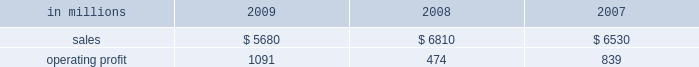Mill in the fourth quarter of 2008 .
This compares with 635000 tons of total downtime in 2008 of which 305000 tons were lack-of-order downtime .
Printing papers in millions 2009 2008 2007 .
North american printing papers net sales in 2009 were $ 2.8 billion compared with $ 3.4 billion in 2008 and $ 3.5 billion in 2007 .
Operating earnings in 2009 were $ 746 million ( $ 307 million excluding alter- native fuel mixture credits and plant closure costs ) compared with $ 405 million ( $ 435 million excluding shutdown costs for a paper machine ) in 2008 and $ 415 million in 2007 .
Sales volumes decreased sig- nificantly in 2009 compared with 2008 reflecting weak customer demand and reduced production capacity resulting from the shutdown of a paper machine at the franklin mill in december 2008 and the conversion of the bastrop mill to pulp production in june 2008 .
Average sales price realizations were lower reflecting slight declines for uncoated freesheet paper in domestic markets and significant declines in export markets .
Margins were also unfavorably affected by a higher proportion of shipments to lower-margin export markets .
Input costs , however , were favorable due to lower wood and chemical costs and sig- nificantly lower energy costs .
Freight costs were also lower .
Planned maintenance downtime costs in 2009 were comparable with 2008 .
Operating costs were favorable , reflecting cost control efforts and strong machine performance .
Lack-of-order downtime increased to 525000 tons in 2009 , including 120000 tons related to the shutdown of a paper machine at our franklin mill in the 2008 fourth quarter , from 135000 tons in 2008 .
Operating earnings in 2009 included $ 671 million of alternative fuel mixture cred- its , $ 223 million of costs associated with the shutdown of our franklin mill and $ 9 million of other shutdown costs , while operating earnings in 2008 included $ 30 million of costs for the shutdown of a paper machine at our franklin mill .
Looking ahead to 2010 , first-quarter sales volumes are expected to increase slightly from fourth-quarter 2009 levels .
Average sales price realizations should be higher , reflecting the full-quarter impact of sales price increases announced in the fourth quarter for converting and envelope grades of uncoated free- sheet paper and an increase in prices to export markets .
However , input costs for wood , energy and chemicals are expected to continue to increase .
Planned maintenance downtime costs should be lower and operating costs should be favorable .
Brazil ian papers net sales for 2009 of $ 960 mil- lion increased from $ 950 million in 2008 and $ 850 million in 2007 .
Operating profits for 2009 were $ 112 million compared with $ 186 million in 2008 and $ 174 million in 2007 .
Sales volumes increased in 2009 compared with 2008 for both paper and pulp reflect- ing higher export shipments .
Average sales price realizations were lower due to strong competitive pressures in the brazilian domestic market in the second half of the year , lower export prices and unfavorable foreign exchange rates .
Margins were unfavorably affected by a higher proportion of lower margin export sales .
Input costs for wood and chem- icals were favorable , but these benefits were partially offset by higher energy costs .
Planned maintenance downtime costs were lower , and operating costs were also favorable .
Earnings in 2009 were adversely impacted by unfavorable foreign exchange effects .
Entering 2010 , sales volumes are expected to be seasonally lower compared with the fourth quarter of 2009 .
Profit margins are expected to be slightly higher reflecting a more favorable geographic sales mix and improving sales price realizations in export markets , partially offset by higher planned main- tenance outage costs .
European papers net sales in 2009 were $ 1.3 bil- lion compared with $ 1.7 billion in 2008 and $ 1.5 bil- lion in 2007 .
Operating profits in 2009 of $ 92 million ( $ 115 million excluding expenses associated with the closure of the inverurie mill ) compared with $ 39 mil- lion ( $ 146 million excluding a charge to reduce the carrying value of the fixed assets at the inverurie , scotland mill to their estimated realizable value ) in 2008 and $ 171 million in 2007 .
Sales volumes in 2009 were lower than in 2008 primarily due to reduced sales of uncoated freesheet paper following the closure of the inverurie mill in 2009 .
Average sales price realizations decreased significantly in 2009 across most of western europe , but margins increased in poland and russia reflecting the effect of local currency devaluations .
Input costs were favorable as lower wood costs , particularly in russia , were only partially offset by higher energy costs in poland and higher chemical costs .
Planned main- tenance downtime costs were higher in 2009 than in 2008 , while manufacturing operating costs were lower .
Operating profits in 2009 also reflect favorable foreign exchange impacts .
Looking ahead to 2010 , sales volumes are expected to decline from strong 2009 fourth-quarter levels despite solid customer demand .
Average sales price realizations are expected to increase over the quar- ter , primarily in eastern europe , as price increases .
What is the average operating profit? 
Rationale: it is the sum of values divided by three to represent the average .
Computations: table_average(operating profit, none)
Answer: 801.33333. 